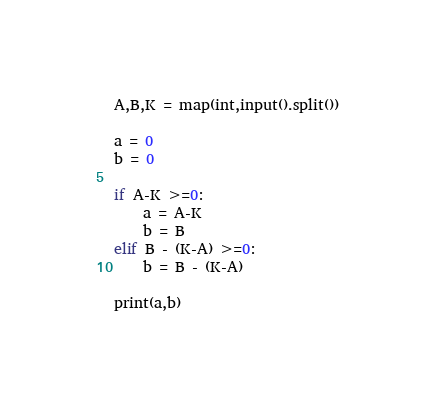Convert code to text. <code><loc_0><loc_0><loc_500><loc_500><_Python_>A,B,K = map(int,input().split())

a = 0
b = 0

if A-K >=0:
    a = A-K
    b = B
elif B - (K-A) >=0:
    b = B - (K-A)

print(a,b)</code> 